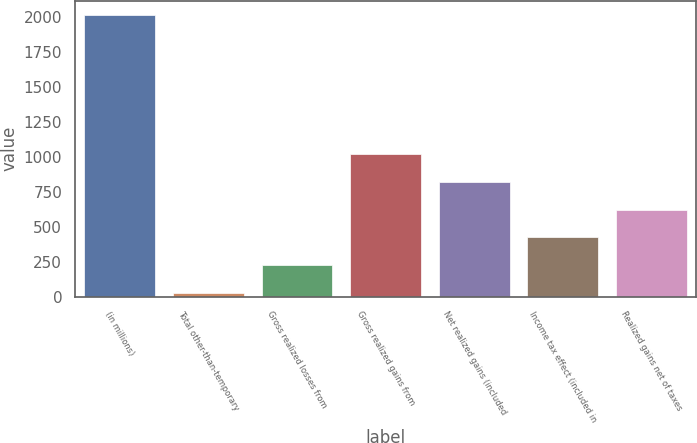Convert chart. <chart><loc_0><loc_0><loc_500><loc_500><bar_chart><fcel>(in millions)<fcel>Total other-than-temporary<fcel>Gross realized losses from<fcel>Gross realized gains from<fcel>Net realized gains (included<fcel>Income tax effect (included in<fcel>Realized gains net of taxes<nl><fcel>2014<fcel>26<fcel>224.8<fcel>1020<fcel>821.2<fcel>423.6<fcel>622.4<nl></chart> 